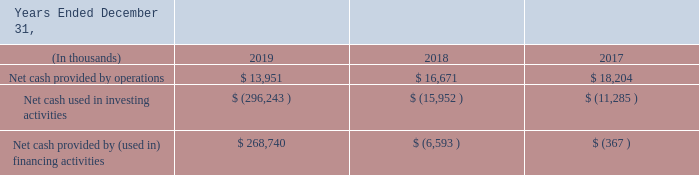Sources and Uses of Cash
Our primary source of liquidity from operations was the collection of revenue in advance from our customers, accounts receivable from our customers, and the management of the timing of payments to our vendors and service providers.
Investing activities in 2019 consist of $284.6 million, net of cash acquired, used in the acquisitions of AppRiver and DeliverySlip and $11.7 million for capital expenditures, which include $8.2 million in internal-use software costs, and $3.5 million for computer and networking equipment. These investments in new equipment and cloud hosting infrastructure are to renovate our business processes and product offerings.
Investing activities in 2018 consist of $11.8 million, net of cash acquired, used in the acquisition of Erado and $4.2 million for capital expenditures, which include $2.1 million for computer and networking equipment, $1.5 million in internal-use software costs, and $500 thousand for other activities including the acquisition of other internal use software. These investments in new equipment and cloud hosting infrastructure were to modernize our business processes and product offerings.
Financing activities in 2019 includes proceeds from long term debt of $179.2 million, net of issuance costs of $6.4 million and repayment of $1.4 million, as well as $96.6 million, net of issuance costs, raised through the private purchase of preferred stock, and $415 thousand received from the exercise of stock options. The proceeds from our debt and preferred stock issuances were used to fund our AppRiver acquisition in February 2019 and our DeliverySlip acquisition in May 2019. We also used $3.8 million for contingent consideration payments associated with our acquisitions of Greenview, Erado and DeliverySlip. In addition to these items, we paid $1.7 million to satisfy finance lease liabilities and $1.9 million to repurchase common stock related to the tax impact of vesting restricted awards in 2019.
Financing activities in 2018 relate primarily to $5.4 million used in a $10 million share repurchase program authorized by our Board of Directors on April 24, 2017, and $656 thousand used in the repurchase of common stock related to the tax impact of vesting restricted stock awards, and a $605 thousand earn-out payment associated with our acquisition of Greenview. Financing activities in 2017 include $3.8 million used in the same share repurchase program and $762 thousand used in the repurchase of common stock related to the tax impact of vesting restricted awards offset by the receipt of $4.2 million from the exercise of stock options.
What was the amount used for capital expenditures in investing activities in 2018 and 2019? 4.2 million, 11.7 million. Which acquisitions made use of proceeds from the company's debt and preferred stock issuances in February 2019 and May 2019 respectively? Appriver, deliveryslip. What are the company's primary source of liquidity from operations? The collection of revenue in advance from our customers, accounts receivable from our customers, and the management of the timing of payments to our vendors and service providers. Which year had the highest Net cash provided by operations? 18,204> 16,671> 13,951
Answer: 2017. What is the percentage change in Net cash provided by operations from 2017 to 2018?
Answer scale should be: percent. (16,671-18,204)/18,204
Answer: -8.42. For how many years was the Net cash used in financing activities more than $100,000? 2019
Answer: 1. 